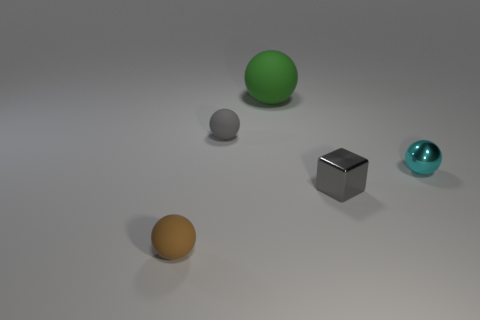Are there any other things that have the same shape as the gray metallic object?
Ensure brevity in your answer.  No. What is the ball that is in front of the thing that is right of the gray object that is right of the green ball made of?
Your answer should be very brief. Rubber. What number of other things are there of the same size as the gray cube?
Offer a terse response. 3. What size is the rubber object that is the same color as the tiny shiny block?
Offer a very short reply. Small. Are there more objects to the right of the tiny gray cube than tiny gray rubber things?
Your answer should be very brief. No. Is there a metallic block of the same color as the large object?
Give a very brief answer. No. There is a cube that is the same size as the cyan ball; what is its color?
Offer a terse response. Gray. How many tiny gray things are left of the small sphere to the right of the large thing?
Keep it short and to the point. 2. What number of objects are matte things that are behind the small brown matte sphere or spheres?
Ensure brevity in your answer.  4. How many large yellow cylinders are made of the same material as the gray block?
Provide a succinct answer. 0. 